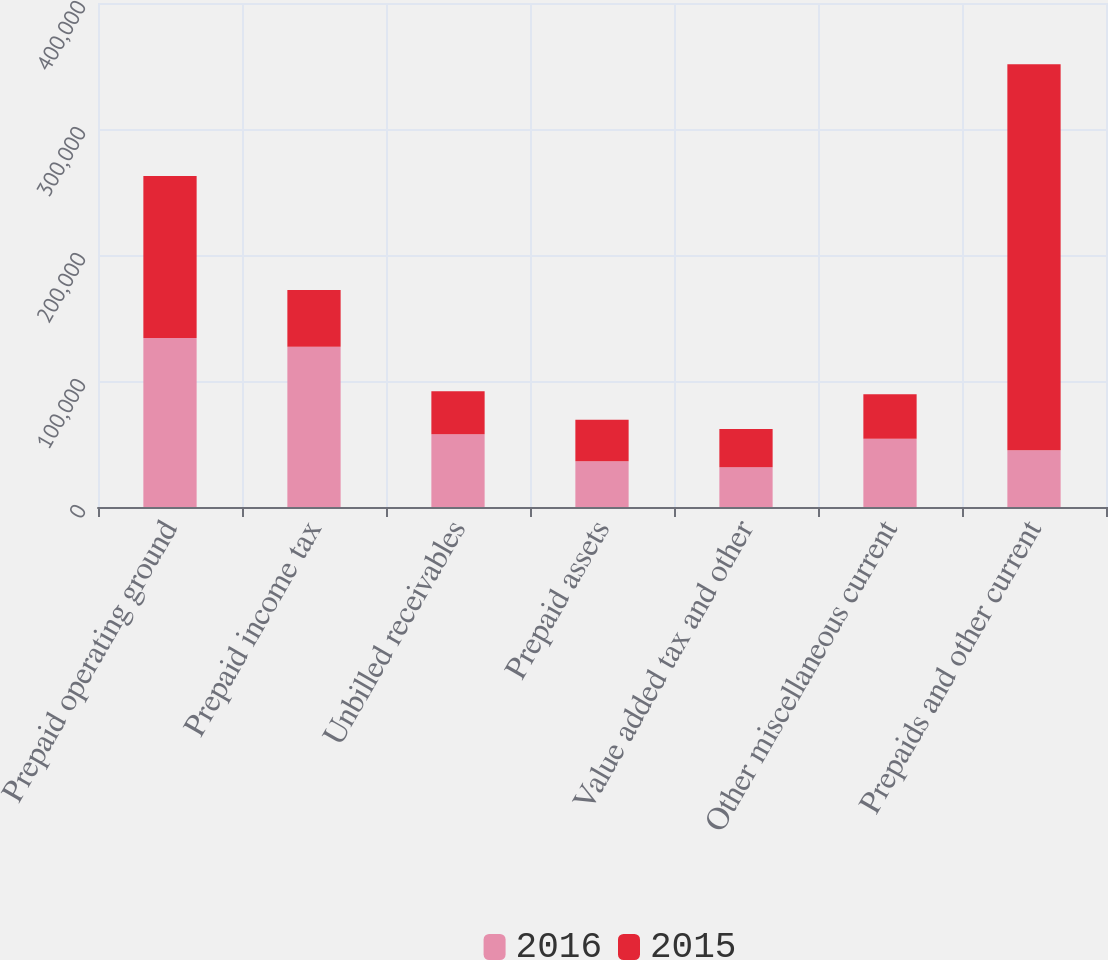Convert chart. <chart><loc_0><loc_0><loc_500><loc_500><stacked_bar_chart><ecel><fcel>Prepaid operating ground<fcel>Prepaid income tax<fcel>Unbilled receivables<fcel>Prepaid assets<fcel>Value added tax and other<fcel>Other miscellaneous current<fcel>Prepaids and other current<nl><fcel>2016<fcel>134167<fcel>127142<fcel>57661<fcel>36300<fcel>31570<fcel>54193<fcel>45056<nl><fcel>2015<fcel>128542<fcel>45056<fcel>34173<fcel>32892<fcel>30239<fcel>35333<fcel>306235<nl></chart> 